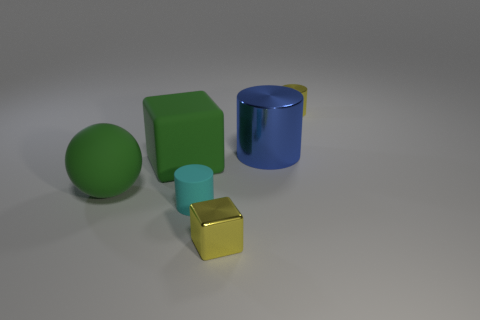Subtract all small cylinders. How many cylinders are left? 1 Add 3 green metal things. How many objects exist? 9 Subtract all spheres. How many objects are left? 5 Add 2 big blue objects. How many big blue objects exist? 3 Subtract 0 green cylinders. How many objects are left? 6 Subtract all green cylinders. Subtract all gray balls. How many cylinders are left? 3 Subtract all tiny matte objects. Subtract all tiny yellow rubber balls. How many objects are left? 5 Add 1 matte cubes. How many matte cubes are left? 2 